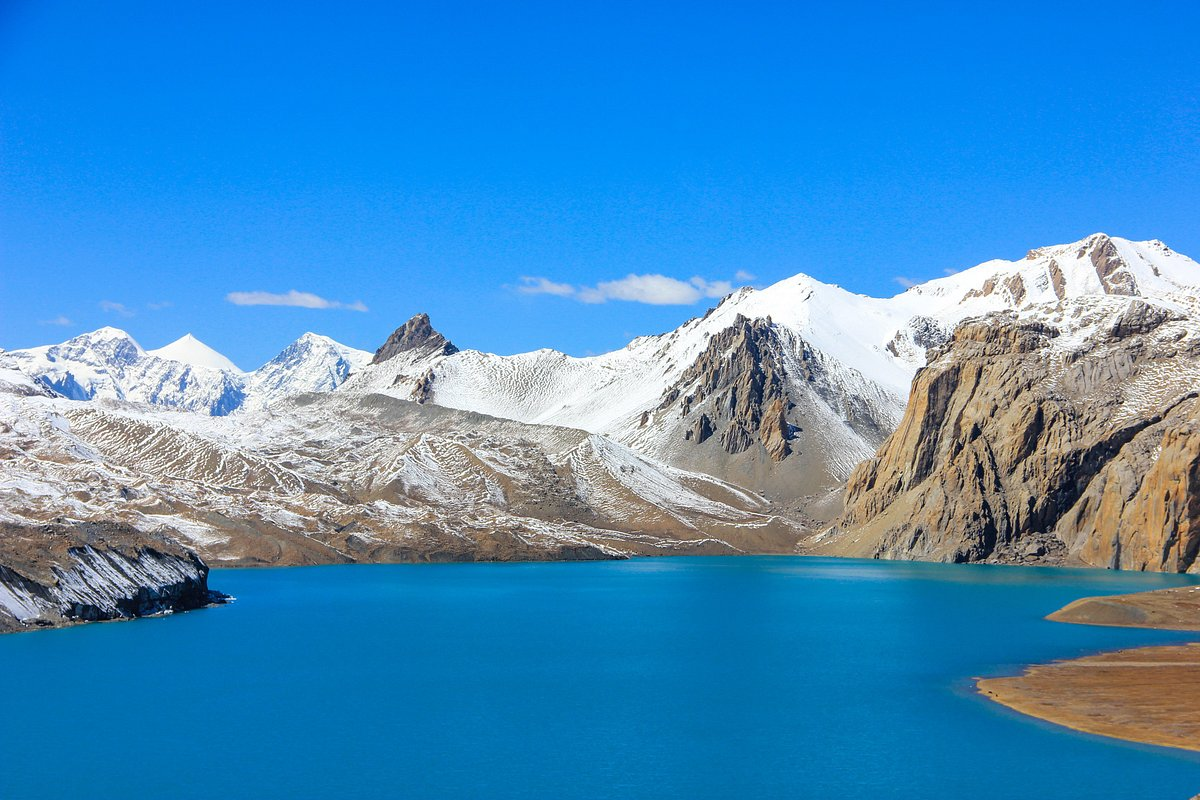Imagine a fantasy story that could take place at this beautiful lake. Can you create a short premise? In a distant epoch, Tilicho Lake was believed to be the gateway to a hidden realm where the spirits of the ancient Himalayan guardians resided. According to legend, the shimmering blue waters protected the entrance to a mystical kingdom beneath the lake, where ethereal beings guided the balance of nature. Only those with a pure heart and unyielding courage could unlock the path to this secret world. The story follows a young adventurer, Arya, who embarks on a quest to save her village from an inexplicable drought by uncovering the secrets of Tilicho Lake. With the help of a guide, a reclusive guardian of the mountains, she ventures to the lake, facing formidable natural challenges and learning profound truths about harmony and bravery. 